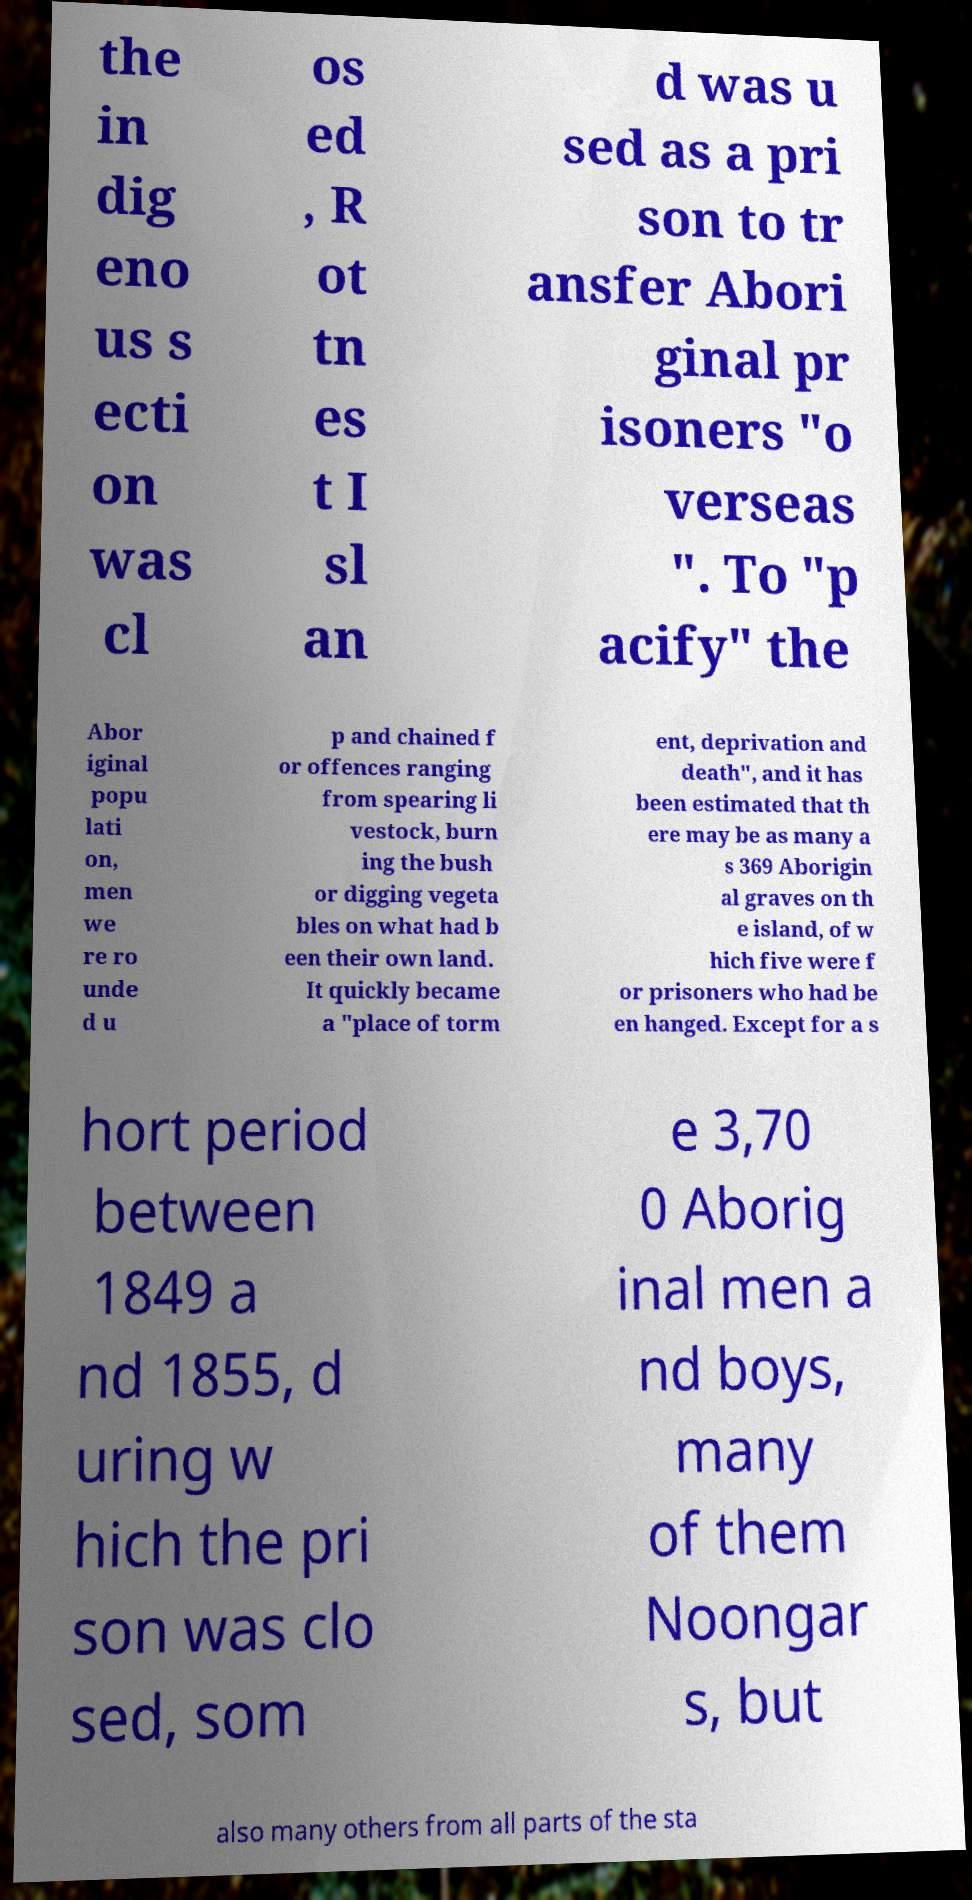There's text embedded in this image that I need extracted. Can you transcribe it verbatim? the in dig eno us s ecti on was cl os ed , R ot tn es t I sl an d was u sed as a pri son to tr ansfer Abori ginal pr isoners "o verseas ". To "p acify" the Abor iginal popu lati on, men we re ro unde d u p and chained f or offences ranging from spearing li vestock, burn ing the bush or digging vegeta bles on what had b een their own land. It quickly became a "place of torm ent, deprivation and death", and it has been estimated that th ere may be as many a s 369 Aborigin al graves on th e island, of w hich five were f or prisoners who had be en hanged. Except for a s hort period between 1849 a nd 1855, d uring w hich the pri son was clo sed, som e 3,70 0 Aborig inal men a nd boys, many of them Noongar s, but also many others from all parts of the sta 